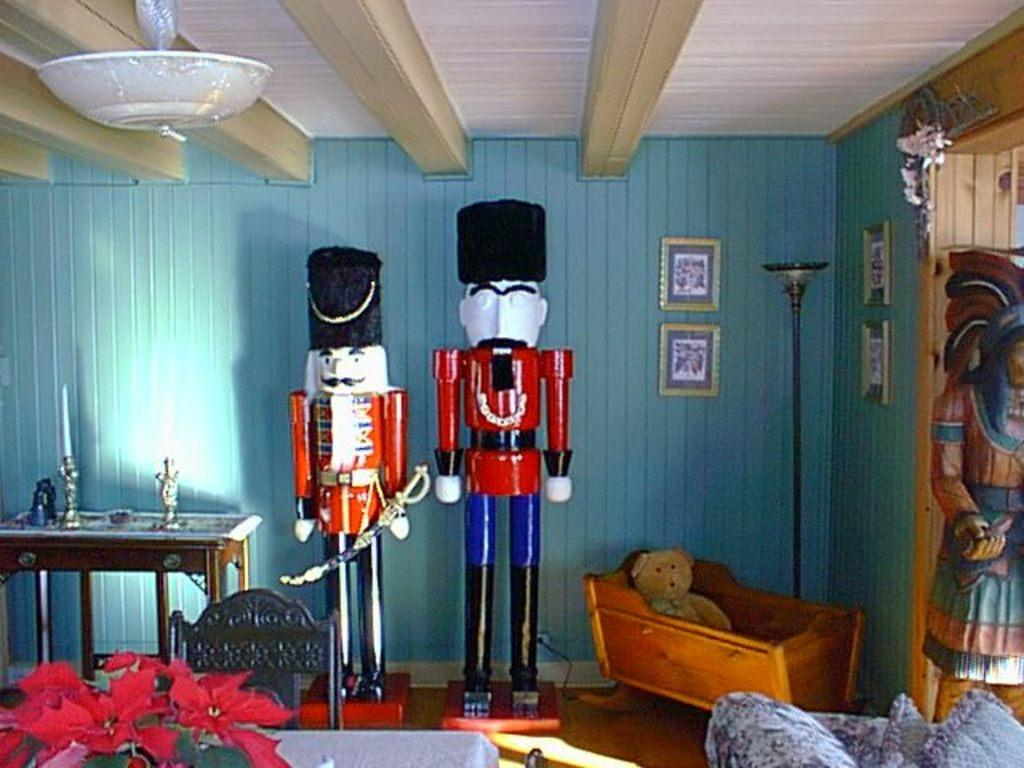What is the main subject of the image? The main subject of the image is a statue of a man. What is the statue of the man doing? The statue depicts the man standing. What type of plantation can be seen in the background of the image? There is no plantation present in the image; it only features a statue of a man. What color is the silverware used by the man in the image? There is no man or silverware present in the image; it only features a statue of a man. 